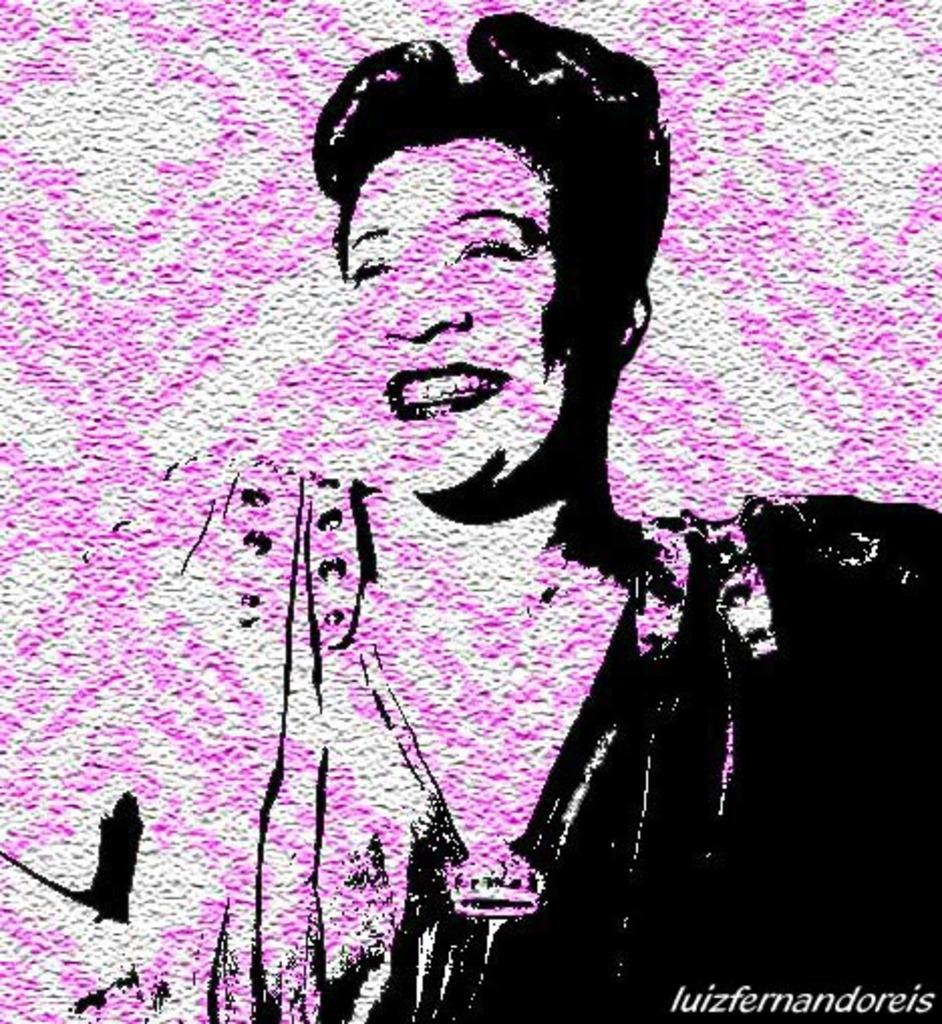What is depicted on the wall in the image? There is a sketch of a person on the wall. What else can be seen in the image besides the sketch? There is some text in the image. What type of fowl can be seen interacting with the sketch on the wall? There is no fowl present in the image; it only features a sketch of a person and some text. 